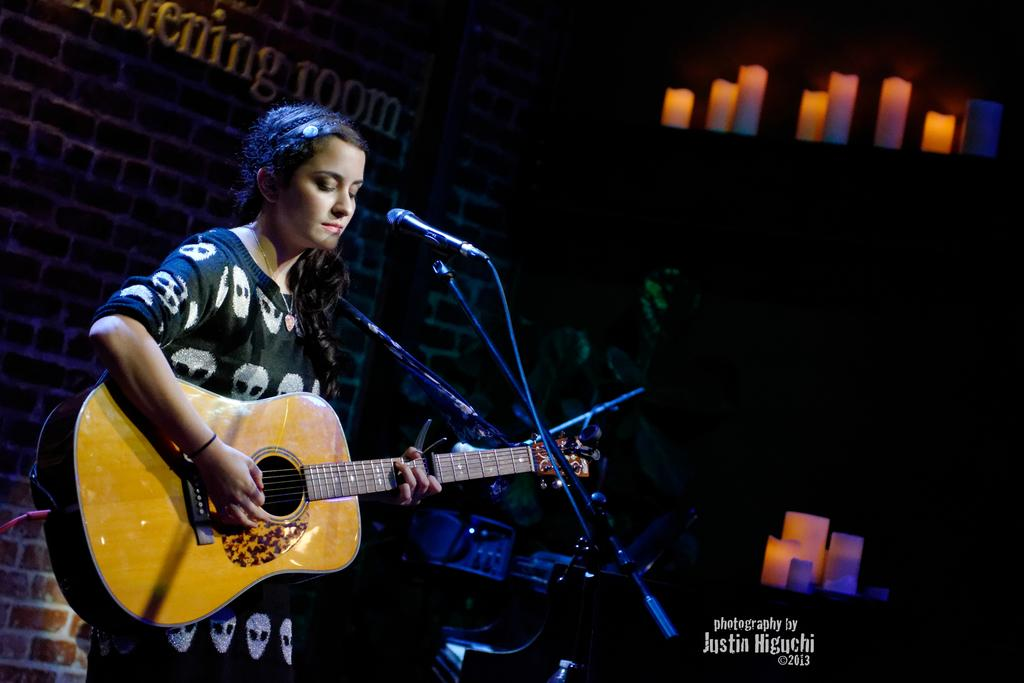What is the person in the image holding? The person is holding a guitar. What object is present for amplifying sound in the image? There is a microphone with a stand in the image. What can be seen in the background of the image? There is a wall and candles in the background of the image. What type of fuel is being used by the straw in the image? There is no straw present in the image, so it is not possible to determine what type of fuel it might be using. 